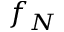<formula> <loc_0><loc_0><loc_500><loc_500>f _ { N }</formula> 